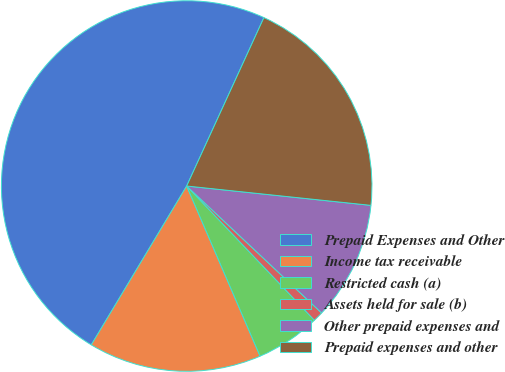Convert chart. <chart><loc_0><loc_0><loc_500><loc_500><pie_chart><fcel>Prepaid Expenses and Other<fcel>Income tax receivable<fcel>Restricted cash (a)<fcel>Assets held for sale (b)<fcel>Other prepaid expenses and<fcel>Prepaid expenses and other<nl><fcel>48.23%<fcel>15.09%<fcel>5.62%<fcel>0.88%<fcel>10.35%<fcel>19.82%<nl></chart> 